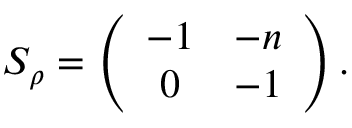<formula> <loc_0><loc_0><loc_500><loc_500>S _ { \rho } = \left ( \begin{array} { c c } { - 1 } & { - n } \\ { 0 } & { - 1 } \end{array} \right ) .</formula> 